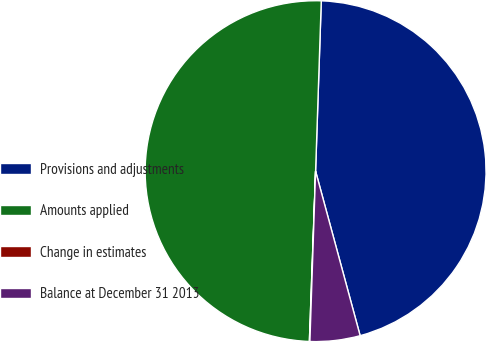Convert chart. <chart><loc_0><loc_0><loc_500><loc_500><pie_chart><fcel>Provisions and adjustments<fcel>Amounts applied<fcel>Change in estimates<fcel>Balance at December 31 2013<nl><fcel>45.26%<fcel>49.95%<fcel>0.05%<fcel>4.74%<nl></chart> 